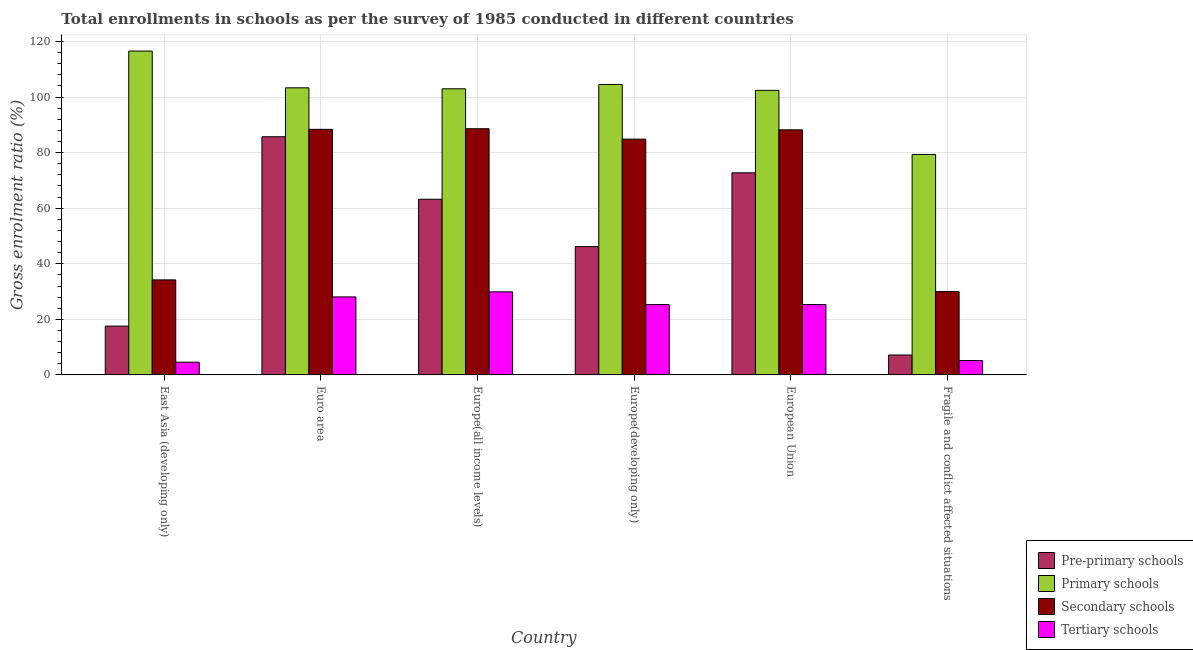How many groups of bars are there?
Keep it short and to the point. 6. How many bars are there on the 2nd tick from the left?
Give a very brief answer. 4. What is the gross enrolment ratio in pre-primary schools in Europe(developing only)?
Your response must be concise. 46.2. Across all countries, what is the maximum gross enrolment ratio in pre-primary schools?
Offer a very short reply. 85.72. Across all countries, what is the minimum gross enrolment ratio in secondary schools?
Give a very brief answer. 30.01. In which country was the gross enrolment ratio in primary schools maximum?
Provide a succinct answer. East Asia (developing only). In which country was the gross enrolment ratio in secondary schools minimum?
Your answer should be very brief. Fragile and conflict affected situations. What is the total gross enrolment ratio in tertiary schools in the graph?
Give a very brief answer. 118.38. What is the difference between the gross enrolment ratio in pre-primary schools in Euro area and that in Fragile and conflict affected situations?
Give a very brief answer. 78.56. What is the difference between the gross enrolment ratio in secondary schools in European Union and the gross enrolment ratio in tertiary schools in East Asia (developing only)?
Offer a very short reply. 83.63. What is the average gross enrolment ratio in secondary schools per country?
Ensure brevity in your answer.  69.05. What is the difference between the gross enrolment ratio in tertiary schools and gross enrolment ratio in pre-primary schools in Fragile and conflict affected situations?
Provide a succinct answer. -1.99. What is the ratio of the gross enrolment ratio in pre-primary schools in Europe(developing only) to that in Fragile and conflict affected situations?
Your response must be concise. 6.45. Is the gross enrolment ratio in secondary schools in Europe(all income levels) less than that in Europe(developing only)?
Your answer should be very brief. No. What is the difference between the highest and the second highest gross enrolment ratio in tertiary schools?
Offer a very short reply. 1.82. What is the difference between the highest and the lowest gross enrolment ratio in primary schools?
Your answer should be compact. 37.2. Is it the case that in every country, the sum of the gross enrolment ratio in tertiary schools and gross enrolment ratio in primary schools is greater than the sum of gross enrolment ratio in secondary schools and gross enrolment ratio in pre-primary schools?
Give a very brief answer. No. What does the 1st bar from the left in Europe(developing only) represents?
Your answer should be compact. Pre-primary schools. What does the 1st bar from the right in Europe(all income levels) represents?
Your answer should be compact. Tertiary schools. Are all the bars in the graph horizontal?
Keep it short and to the point. No. What is the difference between two consecutive major ticks on the Y-axis?
Offer a terse response. 20. How are the legend labels stacked?
Provide a succinct answer. Vertical. What is the title of the graph?
Provide a succinct answer. Total enrollments in schools as per the survey of 1985 conducted in different countries. What is the label or title of the X-axis?
Offer a terse response. Country. What is the Gross enrolment ratio (%) in Pre-primary schools in East Asia (developing only)?
Your answer should be compact. 17.57. What is the Gross enrolment ratio (%) of Primary schools in East Asia (developing only)?
Give a very brief answer. 116.56. What is the Gross enrolment ratio (%) of Secondary schools in East Asia (developing only)?
Provide a succinct answer. 34.21. What is the Gross enrolment ratio (%) of Tertiary schools in East Asia (developing only)?
Offer a terse response. 4.58. What is the Gross enrolment ratio (%) of Pre-primary schools in Euro area?
Make the answer very short. 85.72. What is the Gross enrolment ratio (%) of Primary schools in Euro area?
Provide a succinct answer. 103.33. What is the Gross enrolment ratio (%) in Secondary schools in Euro area?
Provide a succinct answer. 88.39. What is the Gross enrolment ratio (%) in Tertiary schools in Euro area?
Your answer should be very brief. 28.08. What is the Gross enrolment ratio (%) in Pre-primary schools in Europe(all income levels)?
Make the answer very short. 63.23. What is the Gross enrolment ratio (%) in Primary schools in Europe(all income levels)?
Provide a short and direct response. 102.99. What is the Gross enrolment ratio (%) in Secondary schools in Europe(all income levels)?
Offer a terse response. 88.61. What is the Gross enrolment ratio (%) in Tertiary schools in Europe(all income levels)?
Offer a very short reply. 29.9. What is the Gross enrolment ratio (%) in Pre-primary schools in Europe(developing only)?
Give a very brief answer. 46.2. What is the Gross enrolment ratio (%) of Primary schools in Europe(developing only)?
Provide a succinct answer. 104.55. What is the Gross enrolment ratio (%) of Secondary schools in Europe(developing only)?
Offer a very short reply. 84.86. What is the Gross enrolment ratio (%) of Tertiary schools in Europe(developing only)?
Offer a very short reply. 25.32. What is the Gross enrolment ratio (%) in Pre-primary schools in European Union?
Your answer should be compact. 72.74. What is the Gross enrolment ratio (%) of Primary schools in European Union?
Your answer should be compact. 102.42. What is the Gross enrolment ratio (%) of Secondary schools in European Union?
Give a very brief answer. 88.21. What is the Gross enrolment ratio (%) in Tertiary schools in European Union?
Provide a short and direct response. 25.33. What is the Gross enrolment ratio (%) of Pre-primary schools in Fragile and conflict affected situations?
Give a very brief answer. 7.16. What is the Gross enrolment ratio (%) of Primary schools in Fragile and conflict affected situations?
Make the answer very short. 79.36. What is the Gross enrolment ratio (%) in Secondary schools in Fragile and conflict affected situations?
Ensure brevity in your answer.  30.01. What is the Gross enrolment ratio (%) of Tertiary schools in Fragile and conflict affected situations?
Your answer should be compact. 5.17. Across all countries, what is the maximum Gross enrolment ratio (%) of Pre-primary schools?
Make the answer very short. 85.72. Across all countries, what is the maximum Gross enrolment ratio (%) of Primary schools?
Provide a short and direct response. 116.56. Across all countries, what is the maximum Gross enrolment ratio (%) of Secondary schools?
Your answer should be very brief. 88.61. Across all countries, what is the maximum Gross enrolment ratio (%) in Tertiary schools?
Provide a short and direct response. 29.9. Across all countries, what is the minimum Gross enrolment ratio (%) of Pre-primary schools?
Provide a succinct answer. 7.16. Across all countries, what is the minimum Gross enrolment ratio (%) of Primary schools?
Your answer should be compact. 79.36. Across all countries, what is the minimum Gross enrolment ratio (%) of Secondary schools?
Ensure brevity in your answer.  30.01. Across all countries, what is the minimum Gross enrolment ratio (%) in Tertiary schools?
Offer a terse response. 4.58. What is the total Gross enrolment ratio (%) of Pre-primary schools in the graph?
Offer a very short reply. 292.62. What is the total Gross enrolment ratio (%) in Primary schools in the graph?
Ensure brevity in your answer.  609.21. What is the total Gross enrolment ratio (%) of Secondary schools in the graph?
Provide a succinct answer. 414.27. What is the total Gross enrolment ratio (%) in Tertiary schools in the graph?
Provide a short and direct response. 118.38. What is the difference between the Gross enrolment ratio (%) in Pre-primary schools in East Asia (developing only) and that in Euro area?
Ensure brevity in your answer.  -68.16. What is the difference between the Gross enrolment ratio (%) in Primary schools in East Asia (developing only) and that in Euro area?
Provide a succinct answer. 13.23. What is the difference between the Gross enrolment ratio (%) of Secondary schools in East Asia (developing only) and that in Euro area?
Your answer should be compact. -54.18. What is the difference between the Gross enrolment ratio (%) of Tertiary schools in East Asia (developing only) and that in Euro area?
Make the answer very short. -23.5. What is the difference between the Gross enrolment ratio (%) in Pre-primary schools in East Asia (developing only) and that in Europe(all income levels)?
Provide a short and direct response. -45.66. What is the difference between the Gross enrolment ratio (%) in Primary schools in East Asia (developing only) and that in Europe(all income levels)?
Ensure brevity in your answer.  13.57. What is the difference between the Gross enrolment ratio (%) in Secondary schools in East Asia (developing only) and that in Europe(all income levels)?
Your answer should be compact. -54.4. What is the difference between the Gross enrolment ratio (%) in Tertiary schools in East Asia (developing only) and that in Europe(all income levels)?
Offer a terse response. -25.33. What is the difference between the Gross enrolment ratio (%) of Pre-primary schools in East Asia (developing only) and that in Europe(developing only)?
Offer a terse response. -28.63. What is the difference between the Gross enrolment ratio (%) of Primary schools in East Asia (developing only) and that in Europe(developing only)?
Keep it short and to the point. 12.01. What is the difference between the Gross enrolment ratio (%) in Secondary schools in East Asia (developing only) and that in Europe(developing only)?
Your response must be concise. -50.65. What is the difference between the Gross enrolment ratio (%) of Tertiary schools in East Asia (developing only) and that in Europe(developing only)?
Make the answer very short. -20.74. What is the difference between the Gross enrolment ratio (%) of Pre-primary schools in East Asia (developing only) and that in European Union?
Your answer should be very brief. -55.18. What is the difference between the Gross enrolment ratio (%) in Primary schools in East Asia (developing only) and that in European Union?
Your answer should be very brief. 14.14. What is the difference between the Gross enrolment ratio (%) of Secondary schools in East Asia (developing only) and that in European Union?
Keep it short and to the point. -54. What is the difference between the Gross enrolment ratio (%) in Tertiary schools in East Asia (developing only) and that in European Union?
Offer a very short reply. -20.75. What is the difference between the Gross enrolment ratio (%) in Pre-primary schools in East Asia (developing only) and that in Fragile and conflict affected situations?
Offer a terse response. 10.4. What is the difference between the Gross enrolment ratio (%) of Primary schools in East Asia (developing only) and that in Fragile and conflict affected situations?
Provide a succinct answer. 37.2. What is the difference between the Gross enrolment ratio (%) in Secondary schools in East Asia (developing only) and that in Fragile and conflict affected situations?
Offer a very short reply. 4.2. What is the difference between the Gross enrolment ratio (%) of Tertiary schools in East Asia (developing only) and that in Fragile and conflict affected situations?
Provide a succinct answer. -0.59. What is the difference between the Gross enrolment ratio (%) of Pre-primary schools in Euro area and that in Europe(all income levels)?
Offer a terse response. 22.49. What is the difference between the Gross enrolment ratio (%) of Primary schools in Euro area and that in Europe(all income levels)?
Provide a succinct answer. 0.34. What is the difference between the Gross enrolment ratio (%) in Secondary schools in Euro area and that in Europe(all income levels)?
Your answer should be very brief. -0.22. What is the difference between the Gross enrolment ratio (%) of Tertiary schools in Euro area and that in Europe(all income levels)?
Offer a very short reply. -1.82. What is the difference between the Gross enrolment ratio (%) in Pre-primary schools in Euro area and that in Europe(developing only)?
Ensure brevity in your answer.  39.52. What is the difference between the Gross enrolment ratio (%) in Primary schools in Euro area and that in Europe(developing only)?
Your answer should be very brief. -1.23. What is the difference between the Gross enrolment ratio (%) in Secondary schools in Euro area and that in Europe(developing only)?
Your answer should be very brief. 3.53. What is the difference between the Gross enrolment ratio (%) in Tertiary schools in Euro area and that in Europe(developing only)?
Your response must be concise. 2.76. What is the difference between the Gross enrolment ratio (%) in Pre-primary schools in Euro area and that in European Union?
Offer a terse response. 12.98. What is the difference between the Gross enrolment ratio (%) of Primary schools in Euro area and that in European Union?
Your response must be concise. 0.91. What is the difference between the Gross enrolment ratio (%) in Secondary schools in Euro area and that in European Union?
Ensure brevity in your answer.  0.18. What is the difference between the Gross enrolment ratio (%) of Tertiary schools in Euro area and that in European Union?
Ensure brevity in your answer.  2.75. What is the difference between the Gross enrolment ratio (%) of Pre-primary schools in Euro area and that in Fragile and conflict affected situations?
Your response must be concise. 78.56. What is the difference between the Gross enrolment ratio (%) in Primary schools in Euro area and that in Fragile and conflict affected situations?
Offer a terse response. 23.97. What is the difference between the Gross enrolment ratio (%) of Secondary schools in Euro area and that in Fragile and conflict affected situations?
Your answer should be very brief. 58.39. What is the difference between the Gross enrolment ratio (%) of Tertiary schools in Euro area and that in Fragile and conflict affected situations?
Your response must be concise. 22.91. What is the difference between the Gross enrolment ratio (%) of Pre-primary schools in Europe(all income levels) and that in Europe(developing only)?
Ensure brevity in your answer.  17.03. What is the difference between the Gross enrolment ratio (%) in Primary schools in Europe(all income levels) and that in Europe(developing only)?
Offer a terse response. -1.57. What is the difference between the Gross enrolment ratio (%) in Secondary schools in Europe(all income levels) and that in Europe(developing only)?
Ensure brevity in your answer.  3.75. What is the difference between the Gross enrolment ratio (%) in Tertiary schools in Europe(all income levels) and that in Europe(developing only)?
Your response must be concise. 4.59. What is the difference between the Gross enrolment ratio (%) of Pre-primary schools in Europe(all income levels) and that in European Union?
Give a very brief answer. -9.51. What is the difference between the Gross enrolment ratio (%) in Primary schools in Europe(all income levels) and that in European Union?
Keep it short and to the point. 0.57. What is the difference between the Gross enrolment ratio (%) in Secondary schools in Europe(all income levels) and that in European Union?
Keep it short and to the point. 0.4. What is the difference between the Gross enrolment ratio (%) of Tertiary schools in Europe(all income levels) and that in European Union?
Offer a very short reply. 4.57. What is the difference between the Gross enrolment ratio (%) of Pre-primary schools in Europe(all income levels) and that in Fragile and conflict affected situations?
Ensure brevity in your answer.  56.06. What is the difference between the Gross enrolment ratio (%) in Primary schools in Europe(all income levels) and that in Fragile and conflict affected situations?
Provide a short and direct response. 23.63. What is the difference between the Gross enrolment ratio (%) in Secondary schools in Europe(all income levels) and that in Fragile and conflict affected situations?
Make the answer very short. 58.6. What is the difference between the Gross enrolment ratio (%) of Tertiary schools in Europe(all income levels) and that in Fragile and conflict affected situations?
Ensure brevity in your answer.  24.73. What is the difference between the Gross enrolment ratio (%) in Pre-primary schools in Europe(developing only) and that in European Union?
Ensure brevity in your answer.  -26.54. What is the difference between the Gross enrolment ratio (%) of Primary schools in Europe(developing only) and that in European Union?
Your response must be concise. 2.13. What is the difference between the Gross enrolment ratio (%) in Secondary schools in Europe(developing only) and that in European Union?
Offer a terse response. -3.35. What is the difference between the Gross enrolment ratio (%) in Tertiary schools in Europe(developing only) and that in European Union?
Your answer should be very brief. -0.01. What is the difference between the Gross enrolment ratio (%) in Pre-primary schools in Europe(developing only) and that in Fragile and conflict affected situations?
Offer a terse response. 39.04. What is the difference between the Gross enrolment ratio (%) in Primary schools in Europe(developing only) and that in Fragile and conflict affected situations?
Make the answer very short. 25.2. What is the difference between the Gross enrolment ratio (%) of Secondary schools in Europe(developing only) and that in Fragile and conflict affected situations?
Keep it short and to the point. 54.85. What is the difference between the Gross enrolment ratio (%) of Tertiary schools in Europe(developing only) and that in Fragile and conflict affected situations?
Offer a very short reply. 20.15. What is the difference between the Gross enrolment ratio (%) of Pre-primary schools in European Union and that in Fragile and conflict affected situations?
Provide a short and direct response. 65.58. What is the difference between the Gross enrolment ratio (%) in Primary schools in European Union and that in Fragile and conflict affected situations?
Ensure brevity in your answer.  23.06. What is the difference between the Gross enrolment ratio (%) of Secondary schools in European Union and that in Fragile and conflict affected situations?
Provide a short and direct response. 58.2. What is the difference between the Gross enrolment ratio (%) in Tertiary schools in European Union and that in Fragile and conflict affected situations?
Your response must be concise. 20.16. What is the difference between the Gross enrolment ratio (%) of Pre-primary schools in East Asia (developing only) and the Gross enrolment ratio (%) of Primary schools in Euro area?
Ensure brevity in your answer.  -85.76. What is the difference between the Gross enrolment ratio (%) in Pre-primary schools in East Asia (developing only) and the Gross enrolment ratio (%) in Secondary schools in Euro area?
Offer a terse response. -70.83. What is the difference between the Gross enrolment ratio (%) in Pre-primary schools in East Asia (developing only) and the Gross enrolment ratio (%) in Tertiary schools in Euro area?
Your answer should be very brief. -10.51. What is the difference between the Gross enrolment ratio (%) of Primary schools in East Asia (developing only) and the Gross enrolment ratio (%) of Secondary schools in Euro area?
Provide a succinct answer. 28.17. What is the difference between the Gross enrolment ratio (%) in Primary schools in East Asia (developing only) and the Gross enrolment ratio (%) in Tertiary schools in Euro area?
Your answer should be compact. 88.48. What is the difference between the Gross enrolment ratio (%) in Secondary schools in East Asia (developing only) and the Gross enrolment ratio (%) in Tertiary schools in Euro area?
Your response must be concise. 6.13. What is the difference between the Gross enrolment ratio (%) in Pre-primary schools in East Asia (developing only) and the Gross enrolment ratio (%) in Primary schools in Europe(all income levels)?
Make the answer very short. -85.42. What is the difference between the Gross enrolment ratio (%) of Pre-primary schools in East Asia (developing only) and the Gross enrolment ratio (%) of Secondary schools in Europe(all income levels)?
Provide a short and direct response. -71.04. What is the difference between the Gross enrolment ratio (%) in Pre-primary schools in East Asia (developing only) and the Gross enrolment ratio (%) in Tertiary schools in Europe(all income levels)?
Provide a succinct answer. -12.34. What is the difference between the Gross enrolment ratio (%) in Primary schools in East Asia (developing only) and the Gross enrolment ratio (%) in Secondary schools in Europe(all income levels)?
Your response must be concise. 27.95. What is the difference between the Gross enrolment ratio (%) of Primary schools in East Asia (developing only) and the Gross enrolment ratio (%) of Tertiary schools in Europe(all income levels)?
Your answer should be very brief. 86.66. What is the difference between the Gross enrolment ratio (%) in Secondary schools in East Asia (developing only) and the Gross enrolment ratio (%) in Tertiary schools in Europe(all income levels)?
Provide a short and direct response. 4.3. What is the difference between the Gross enrolment ratio (%) of Pre-primary schools in East Asia (developing only) and the Gross enrolment ratio (%) of Primary schools in Europe(developing only)?
Your answer should be compact. -86.99. What is the difference between the Gross enrolment ratio (%) in Pre-primary schools in East Asia (developing only) and the Gross enrolment ratio (%) in Secondary schools in Europe(developing only)?
Provide a succinct answer. -67.29. What is the difference between the Gross enrolment ratio (%) of Pre-primary schools in East Asia (developing only) and the Gross enrolment ratio (%) of Tertiary schools in Europe(developing only)?
Your answer should be very brief. -7.75. What is the difference between the Gross enrolment ratio (%) in Primary schools in East Asia (developing only) and the Gross enrolment ratio (%) in Secondary schools in Europe(developing only)?
Your answer should be very brief. 31.7. What is the difference between the Gross enrolment ratio (%) of Primary schools in East Asia (developing only) and the Gross enrolment ratio (%) of Tertiary schools in Europe(developing only)?
Offer a very short reply. 91.24. What is the difference between the Gross enrolment ratio (%) in Secondary schools in East Asia (developing only) and the Gross enrolment ratio (%) in Tertiary schools in Europe(developing only)?
Make the answer very short. 8.89. What is the difference between the Gross enrolment ratio (%) in Pre-primary schools in East Asia (developing only) and the Gross enrolment ratio (%) in Primary schools in European Union?
Offer a very short reply. -84.85. What is the difference between the Gross enrolment ratio (%) in Pre-primary schools in East Asia (developing only) and the Gross enrolment ratio (%) in Secondary schools in European Union?
Your answer should be compact. -70.64. What is the difference between the Gross enrolment ratio (%) of Pre-primary schools in East Asia (developing only) and the Gross enrolment ratio (%) of Tertiary schools in European Union?
Make the answer very short. -7.77. What is the difference between the Gross enrolment ratio (%) in Primary schools in East Asia (developing only) and the Gross enrolment ratio (%) in Secondary schools in European Union?
Give a very brief answer. 28.35. What is the difference between the Gross enrolment ratio (%) of Primary schools in East Asia (developing only) and the Gross enrolment ratio (%) of Tertiary schools in European Union?
Your answer should be very brief. 91.23. What is the difference between the Gross enrolment ratio (%) in Secondary schools in East Asia (developing only) and the Gross enrolment ratio (%) in Tertiary schools in European Union?
Offer a very short reply. 8.88. What is the difference between the Gross enrolment ratio (%) of Pre-primary schools in East Asia (developing only) and the Gross enrolment ratio (%) of Primary schools in Fragile and conflict affected situations?
Offer a terse response. -61.79. What is the difference between the Gross enrolment ratio (%) of Pre-primary schools in East Asia (developing only) and the Gross enrolment ratio (%) of Secondary schools in Fragile and conflict affected situations?
Your response must be concise. -12.44. What is the difference between the Gross enrolment ratio (%) in Pre-primary schools in East Asia (developing only) and the Gross enrolment ratio (%) in Tertiary schools in Fragile and conflict affected situations?
Offer a very short reply. 12.39. What is the difference between the Gross enrolment ratio (%) of Primary schools in East Asia (developing only) and the Gross enrolment ratio (%) of Secondary schools in Fragile and conflict affected situations?
Ensure brevity in your answer.  86.56. What is the difference between the Gross enrolment ratio (%) in Primary schools in East Asia (developing only) and the Gross enrolment ratio (%) in Tertiary schools in Fragile and conflict affected situations?
Offer a very short reply. 111.39. What is the difference between the Gross enrolment ratio (%) of Secondary schools in East Asia (developing only) and the Gross enrolment ratio (%) of Tertiary schools in Fragile and conflict affected situations?
Provide a succinct answer. 29.04. What is the difference between the Gross enrolment ratio (%) of Pre-primary schools in Euro area and the Gross enrolment ratio (%) of Primary schools in Europe(all income levels)?
Keep it short and to the point. -17.26. What is the difference between the Gross enrolment ratio (%) in Pre-primary schools in Euro area and the Gross enrolment ratio (%) in Secondary schools in Europe(all income levels)?
Your answer should be very brief. -2.89. What is the difference between the Gross enrolment ratio (%) in Pre-primary schools in Euro area and the Gross enrolment ratio (%) in Tertiary schools in Europe(all income levels)?
Make the answer very short. 55.82. What is the difference between the Gross enrolment ratio (%) of Primary schools in Euro area and the Gross enrolment ratio (%) of Secondary schools in Europe(all income levels)?
Ensure brevity in your answer.  14.72. What is the difference between the Gross enrolment ratio (%) of Primary schools in Euro area and the Gross enrolment ratio (%) of Tertiary schools in Europe(all income levels)?
Offer a terse response. 73.43. What is the difference between the Gross enrolment ratio (%) in Secondary schools in Euro area and the Gross enrolment ratio (%) in Tertiary schools in Europe(all income levels)?
Provide a succinct answer. 58.49. What is the difference between the Gross enrolment ratio (%) in Pre-primary schools in Euro area and the Gross enrolment ratio (%) in Primary schools in Europe(developing only)?
Keep it short and to the point. -18.83. What is the difference between the Gross enrolment ratio (%) in Pre-primary schools in Euro area and the Gross enrolment ratio (%) in Secondary schools in Europe(developing only)?
Your answer should be very brief. 0.87. What is the difference between the Gross enrolment ratio (%) in Pre-primary schools in Euro area and the Gross enrolment ratio (%) in Tertiary schools in Europe(developing only)?
Offer a very short reply. 60.4. What is the difference between the Gross enrolment ratio (%) of Primary schools in Euro area and the Gross enrolment ratio (%) of Secondary schools in Europe(developing only)?
Make the answer very short. 18.47. What is the difference between the Gross enrolment ratio (%) of Primary schools in Euro area and the Gross enrolment ratio (%) of Tertiary schools in Europe(developing only)?
Ensure brevity in your answer.  78.01. What is the difference between the Gross enrolment ratio (%) in Secondary schools in Euro area and the Gross enrolment ratio (%) in Tertiary schools in Europe(developing only)?
Your response must be concise. 63.07. What is the difference between the Gross enrolment ratio (%) of Pre-primary schools in Euro area and the Gross enrolment ratio (%) of Primary schools in European Union?
Offer a very short reply. -16.7. What is the difference between the Gross enrolment ratio (%) in Pre-primary schools in Euro area and the Gross enrolment ratio (%) in Secondary schools in European Union?
Your response must be concise. -2.48. What is the difference between the Gross enrolment ratio (%) in Pre-primary schools in Euro area and the Gross enrolment ratio (%) in Tertiary schools in European Union?
Provide a succinct answer. 60.39. What is the difference between the Gross enrolment ratio (%) in Primary schools in Euro area and the Gross enrolment ratio (%) in Secondary schools in European Union?
Make the answer very short. 15.12. What is the difference between the Gross enrolment ratio (%) of Primary schools in Euro area and the Gross enrolment ratio (%) of Tertiary schools in European Union?
Give a very brief answer. 78. What is the difference between the Gross enrolment ratio (%) in Secondary schools in Euro area and the Gross enrolment ratio (%) in Tertiary schools in European Union?
Make the answer very short. 63.06. What is the difference between the Gross enrolment ratio (%) in Pre-primary schools in Euro area and the Gross enrolment ratio (%) in Primary schools in Fragile and conflict affected situations?
Offer a very short reply. 6.36. What is the difference between the Gross enrolment ratio (%) in Pre-primary schools in Euro area and the Gross enrolment ratio (%) in Secondary schools in Fragile and conflict affected situations?
Provide a short and direct response. 55.72. What is the difference between the Gross enrolment ratio (%) in Pre-primary schools in Euro area and the Gross enrolment ratio (%) in Tertiary schools in Fragile and conflict affected situations?
Your answer should be very brief. 80.55. What is the difference between the Gross enrolment ratio (%) of Primary schools in Euro area and the Gross enrolment ratio (%) of Secondary schools in Fragile and conflict affected situations?
Offer a very short reply. 73.32. What is the difference between the Gross enrolment ratio (%) of Primary schools in Euro area and the Gross enrolment ratio (%) of Tertiary schools in Fragile and conflict affected situations?
Provide a succinct answer. 98.16. What is the difference between the Gross enrolment ratio (%) of Secondary schools in Euro area and the Gross enrolment ratio (%) of Tertiary schools in Fragile and conflict affected situations?
Your answer should be very brief. 83.22. What is the difference between the Gross enrolment ratio (%) of Pre-primary schools in Europe(all income levels) and the Gross enrolment ratio (%) of Primary schools in Europe(developing only)?
Make the answer very short. -41.33. What is the difference between the Gross enrolment ratio (%) of Pre-primary schools in Europe(all income levels) and the Gross enrolment ratio (%) of Secondary schools in Europe(developing only)?
Your answer should be very brief. -21.63. What is the difference between the Gross enrolment ratio (%) in Pre-primary schools in Europe(all income levels) and the Gross enrolment ratio (%) in Tertiary schools in Europe(developing only)?
Your answer should be compact. 37.91. What is the difference between the Gross enrolment ratio (%) in Primary schools in Europe(all income levels) and the Gross enrolment ratio (%) in Secondary schools in Europe(developing only)?
Provide a succinct answer. 18.13. What is the difference between the Gross enrolment ratio (%) in Primary schools in Europe(all income levels) and the Gross enrolment ratio (%) in Tertiary schools in Europe(developing only)?
Offer a terse response. 77.67. What is the difference between the Gross enrolment ratio (%) in Secondary schools in Europe(all income levels) and the Gross enrolment ratio (%) in Tertiary schools in Europe(developing only)?
Provide a short and direct response. 63.29. What is the difference between the Gross enrolment ratio (%) of Pre-primary schools in Europe(all income levels) and the Gross enrolment ratio (%) of Primary schools in European Union?
Offer a very short reply. -39.19. What is the difference between the Gross enrolment ratio (%) in Pre-primary schools in Europe(all income levels) and the Gross enrolment ratio (%) in Secondary schools in European Union?
Make the answer very short. -24.98. What is the difference between the Gross enrolment ratio (%) of Pre-primary schools in Europe(all income levels) and the Gross enrolment ratio (%) of Tertiary schools in European Union?
Provide a succinct answer. 37.9. What is the difference between the Gross enrolment ratio (%) of Primary schools in Europe(all income levels) and the Gross enrolment ratio (%) of Secondary schools in European Union?
Offer a terse response. 14.78. What is the difference between the Gross enrolment ratio (%) in Primary schools in Europe(all income levels) and the Gross enrolment ratio (%) in Tertiary schools in European Union?
Provide a short and direct response. 77.66. What is the difference between the Gross enrolment ratio (%) of Secondary schools in Europe(all income levels) and the Gross enrolment ratio (%) of Tertiary schools in European Union?
Offer a very short reply. 63.28. What is the difference between the Gross enrolment ratio (%) in Pre-primary schools in Europe(all income levels) and the Gross enrolment ratio (%) in Primary schools in Fragile and conflict affected situations?
Provide a succinct answer. -16.13. What is the difference between the Gross enrolment ratio (%) in Pre-primary schools in Europe(all income levels) and the Gross enrolment ratio (%) in Secondary schools in Fragile and conflict affected situations?
Provide a short and direct response. 33.22. What is the difference between the Gross enrolment ratio (%) of Pre-primary schools in Europe(all income levels) and the Gross enrolment ratio (%) of Tertiary schools in Fragile and conflict affected situations?
Provide a short and direct response. 58.06. What is the difference between the Gross enrolment ratio (%) of Primary schools in Europe(all income levels) and the Gross enrolment ratio (%) of Secondary schools in Fragile and conflict affected situations?
Provide a succinct answer. 72.98. What is the difference between the Gross enrolment ratio (%) in Primary schools in Europe(all income levels) and the Gross enrolment ratio (%) in Tertiary schools in Fragile and conflict affected situations?
Provide a short and direct response. 97.82. What is the difference between the Gross enrolment ratio (%) of Secondary schools in Europe(all income levels) and the Gross enrolment ratio (%) of Tertiary schools in Fragile and conflict affected situations?
Keep it short and to the point. 83.44. What is the difference between the Gross enrolment ratio (%) in Pre-primary schools in Europe(developing only) and the Gross enrolment ratio (%) in Primary schools in European Union?
Your response must be concise. -56.22. What is the difference between the Gross enrolment ratio (%) in Pre-primary schools in Europe(developing only) and the Gross enrolment ratio (%) in Secondary schools in European Union?
Ensure brevity in your answer.  -42.01. What is the difference between the Gross enrolment ratio (%) in Pre-primary schools in Europe(developing only) and the Gross enrolment ratio (%) in Tertiary schools in European Union?
Provide a succinct answer. 20.87. What is the difference between the Gross enrolment ratio (%) of Primary schools in Europe(developing only) and the Gross enrolment ratio (%) of Secondary schools in European Union?
Your answer should be compact. 16.35. What is the difference between the Gross enrolment ratio (%) of Primary schools in Europe(developing only) and the Gross enrolment ratio (%) of Tertiary schools in European Union?
Make the answer very short. 79.22. What is the difference between the Gross enrolment ratio (%) in Secondary schools in Europe(developing only) and the Gross enrolment ratio (%) in Tertiary schools in European Union?
Make the answer very short. 59.53. What is the difference between the Gross enrolment ratio (%) of Pre-primary schools in Europe(developing only) and the Gross enrolment ratio (%) of Primary schools in Fragile and conflict affected situations?
Give a very brief answer. -33.16. What is the difference between the Gross enrolment ratio (%) in Pre-primary schools in Europe(developing only) and the Gross enrolment ratio (%) in Secondary schools in Fragile and conflict affected situations?
Keep it short and to the point. 16.2. What is the difference between the Gross enrolment ratio (%) of Pre-primary schools in Europe(developing only) and the Gross enrolment ratio (%) of Tertiary schools in Fragile and conflict affected situations?
Keep it short and to the point. 41.03. What is the difference between the Gross enrolment ratio (%) in Primary schools in Europe(developing only) and the Gross enrolment ratio (%) in Secondary schools in Fragile and conflict affected situations?
Your response must be concise. 74.55. What is the difference between the Gross enrolment ratio (%) in Primary schools in Europe(developing only) and the Gross enrolment ratio (%) in Tertiary schools in Fragile and conflict affected situations?
Keep it short and to the point. 99.38. What is the difference between the Gross enrolment ratio (%) in Secondary schools in Europe(developing only) and the Gross enrolment ratio (%) in Tertiary schools in Fragile and conflict affected situations?
Ensure brevity in your answer.  79.69. What is the difference between the Gross enrolment ratio (%) in Pre-primary schools in European Union and the Gross enrolment ratio (%) in Primary schools in Fragile and conflict affected situations?
Your answer should be compact. -6.62. What is the difference between the Gross enrolment ratio (%) in Pre-primary schools in European Union and the Gross enrolment ratio (%) in Secondary schools in Fragile and conflict affected situations?
Your response must be concise. 42.74. What is the difference between the Gross enrolment ratio (%) of Pre-primary schools in European Union and the Gross enrolment ratio (%) of Tertiary schools in Fragile and conflict affected situations?
Make the answer very short. 67.57. What is the difference between the Gross enrolment ratio (%) in Primary schools in European Union and the Gross enrolment ratio (%) in Secondary schools in Fragile and conflict affected situations?
Your answer should be very brief. 72.42. What is the difference between the Gross enrolment ratio (%) of Primary schools in European Union and the Gross enrolment ratio (%) of Tertiary schools in Fragile and conflict affected situations?
Provide a succinct answer. 97.25. What is the difference between the Gross enrolment ratio (%) of Secondary schools in European Union and the Gross enrolment ratio (%) of Tertiary schools in Fragile and conflict affected situations?
Your answer should be very brief. 83.04. What is the average Gross enrolment ratio (%) in Pre-primary schools per country?
Provide a short and direct response. 48.77. What is the average Gross enrolment ratio (%) in Primary schools per country?
Keep it short and to the point. 101.53. What is the average Gross enrolment ratio (%) in Secondary schools per country?
Provide a short and direct response. 69.05. What is the average Gross enrolment ratio (%) of Tertiary schools per country?
Give a very brief answer. 19.73. What is the difference between the Gross enrolment ratio (%) in Pre-primary schools and Gross enrolment ratio (%) in Primary schools in East Asia (developing only)?
Keep it short and to the point. -98.99. What is the difference between the Gross enrolment ratio (%) of Pre-primary schools and Gross enrolment ratio (%) of Secondary schools in East Asia (developing only)?
Make the answer very short. -16.64. What is the difference between the Gross enrolment ratio (%) of Pre-primary schools and Gross enrolment ratio (%) of Tertiary schools in East Asia (developing only)?
Provide a short and direct response. 12.99. What is the difference between the Gross enrolment ratio (%) in Primary schools and Gross enrolment ratio (%) in Secondary schools in East Asia (developing only)?
Offer a very short reply. 82.35. What is the difference between the Gross enrolment ratio (%) of Primary schools and Gross enrolment ratio (%) of Tertiary schools in East Asia (developing only)?
Keep it short and to the point. 111.98. What is the difference between the Gross enrolment ratio (%) in Secondary schools and Gross enrolment ratio (%) in Tertiary schools in East Asia (developing only)?
Make the answer very short. 29.63. What is the difference between the Gross enrolment ratio (%) of Pre-primary schools and Gross enrolment ratio (%) of Primary schools in Euro area?
Offer a terse response. -17.61. What is the difference between the Gross enrolment ratio (%) in Pre-primary schools and Gross enrolment ratio (%) in Secondary schools in Euro area?
Your response must be concise. -2.67. What is the difference between the Gross enrolment ratio (%) in Pre-primary schools and Gross enrolment ratio (%) in Tertiary schools in Euro area?
Keep it short and to the point. 57.64. What is the difference between the Gross enrolment ratio (%) of Primary schools and Gross enrolment ratio (%) of Secondary schools in Euro area?
Ensure brevity in your answer.  14.94. What is the difference between the Gross enrolment ratio (%) in Primary schools and Gross enrolment ratio (%) in Tertiary schools in Euro area?
Keep it short and to the point. 75.25. What is the difference between the Gross enrolment ratio (%) of Secondary schools and Gross enrolment ratio (%) of Tertiary schools in Euro area?
Keep it short and to the point. 60.31. What is the difference between the Gross enrolment ratio (%) in Pre-primary schools and Gross enrolment ratio (%) in Primary schools in Europe(all income levels)?
Give a very brief answer. -39.76. What is the difference between the Gross enrolment ratio (%) of Pre-primary schools and Gross enrolment ratio (%) of Secondary schools in Europe(all income levels)?
Ensure brevity in your answer.  -25.38. What is the difference between the Gross enrolment ratio (%) in Pre-primary schools and Gross enrolment ratio (%) in Tertiary schools in Europe(all income levels)?
Offer a terse response. 33.33. What is the difference between the Gross enrolment ratio (%) in Primary schools and Gross enrolment ratio (%) in Secondary schools in Europe(all income levels)?
Give a very brief answer. 14.38. What is the difference between the Gross enrolment ratio (%) of Primary schools and Gross enrolment ratio (%) of Tertiary schools in Europe(all income levels)?
Your answer should be compact. 73.08. What is the difference between the Gross enrolment ratio (%) in Secondary schools and Gross enrolment ratio (%) in Tertiary schools in Europe(all income levels)?
Keep it short and to the point. 58.7. What is the difference between the Gross enrolment ratio (%) in Pre-primary schools and Gross enrolment ratio (%) in Primary schools in Europe(developing only)?
Make the answer very short. -58.35. What is the difference between the Gross enrolment ratio (%) of Pre-primary schools and Gross enrolment ratio (%) of Secondary schools in Europe(developing only)?
Make the answer very short. -38.66. What is the difference between the Gross enrolment ratio (%) of Pre-primary schools and Gross enrolment ratio (%) of Tertiary schools in Europe(developing only)?
Offer a very short reply. 20.88. What is the difference between the Gross enrolment ratio (%) of Primary schools and Gross enrolment ratio (%) of Secondary schools in Europe(developing only)?
Provide a short and direct response. 19.7. What is the difference between the Gross enrolment ratio (%) of Primary schools and Gross enrolment ratio (%) of Tertiary schools in Europe(developing only)?
Give a very brief answer. 79.24. What is the difference between the Gross enrolment ratio (%) in Secondary schools and Gross enrolment ratio (%) in Tertiary schools in Europe(developing only)?
Your response must be concise. 59.54. What is the difference between the Gross enrolment ratio (%) in Pre-primary schools and Gross enrolment ratio (%) in Primary schools in European Union?
Make the answer very short. -29.68. What is the difference between the Gross enrolment ratio (%) in Pre-primary schools and Gross enrolment ratio (%) in Secondary schools in European Union?
Provide a short and direct response. -15.46. What is the difference between the Gross enrolment ratio (%) in Pre-primary schools and Gross enrolment ratio (%) in Tertiary schools in European Union?
Your answer should be very brief. 47.41. What is the difference between the Gross enrolment ratio (%) in Primary schools and Gross enrolment ratio (%) in Secondary schools in European Union?
Offer a very short reply. 14.21. What is the difference between the Gross enrolment ratio (%) of Primary schools and Gross enrolment ratio (%) of Tertiary schools in European Union?
Your answer should be very brief. 77.09. What is the difference between the Gross enrolment ratio (%) of Secondary schools and Gross enrolment ratio (%) of Tertiary schools in European Union?
Your answer should be compact. 62.88. What is the difference between the Gross enrolment ratio (%) of Pre-primary schools and Gross enrolment ratio (%) of Primary schools in Fragile and conflict affected situations?
Make the answer very short. -72.19. What is the difference between the Gross enrolment ratio (%) of Pre-primary schools and Gross enrolment ratio (%) of Secondary schools in Fragile and conflict affected situations?
Your answer should be very brief. -22.84. What is the difference between the Gross enrolment ratio (%) of Pre-primary schools and Gross enrolment ratio (%) of Tertiary schools in Fragile and conflict affected situations?
Provide a succinct answer. 1.99. What is the difference between the Gross enrolment ratio (%) of Primary schools and Gross enrolment ratio (%) of Secondary schools in Fragile and conflict affected situations?
Give a very brief answer. 49.35. What is the difference between the Gross enrolment ratio (%) in Primary schools and Gross enrolment ratio (%) in Tertiary schools in Fragile and conflict affected situations?
Your answer should be very brief. 74.19. What is the difference between the Gross enrolment ratio (%) in Secondary schools and Gross enrolment ratio (%) in Tertiary schools in Fragile and conflict affected situations?
Your response must be concise. 24.83. What is the ratio of the Gross enrolment ratio (%) in Pre-primary schools in East Asia (developing only) to that in Euro area?
Give a very brief answer. 0.2. What is the ratio of the Gross enrolment ratio (%) of Primary schools in East Asia (developing only) to that in Euro area?
Your answer should be very brief. 1.13. What is the ratio of the Gross enrolment ratio (%) of Secondary schools in East Asia (developing only) to that in Euro area?
Provide a short and direct response. 0.39. What is the ratio of the Gross enrolment ratio (%) in Tertiary schools in East Asia (developing only) to that in Euro area?
Ensure brevity in your answer.  0.16. What is the ratio of the Gross enrolment ratio (%) of Pre-primary schools in East Asia (developing only) to that in Europe(all income levels)?
Your answer should be compact. 0.28. What is the ratio of the Gross enrolment ratio (%) in Primary schools in East Asia (developing only) to that in Europe(all income levels)?
Make the answer very short. 1.13. What is the ratio of the Gross enrolment ratio (%) of Secondary schools in East Asia (developing only) to that in Europe(all income levels)?
Your answer should be compact. 0.39. What is the ratio of the Gross enrolment ratio (%) in Tertiary schools in East Asia (developing only) to that in Europe(all income levels)?
Offer a terse response. 0.15. What is the ratio of the Gross enrolment ratio (%) in Pre-primary schools in East Asia (developing only) to that in Europe(developing only)?
Your response must be concise. 0.38. What is the ratio of the Gross enrolment ratio (%) of Primary schools in East Asia (developing only) to that in Europe(developing only)?
Offer a very short reply. 1.11. What is the ratio of the Gross enrolment ratio (%) in Secondary schools in East Asia (developing only) to that in Europe(developing only)?
Provide a succinct answer. 0.4. What is the ratio of the Gross enrolment ratio (%) in Tertiary schools in East Asia (developing only) to that in Europe(developing only)?
Give a very brief answer. 0.18. What is the ratio of the Gross enrolment ratio (%) of Pre-primary schools in East Asia (developing only) to that in European Union?
Give a very brief answer. 0.24. What is the ratio of the Gross enrolment ratio (%) of Primary schools in East Asia (developing only) to that in European Union?
Provide a succinct answer. 1.14. What is the ratio of the Gross enrolment ratio (%) of Secondary schools in East Asia (developing only) to that in European Union?
Make the answer very short. 0.39. What is the ratio of the Gross enrolment ratio (%) in Tertiary schools in East Asia (developing only) to that in European Union?
Give a very brief answer. 0.18. What is the ratio of the Gross enrolment ratio (%) in Pre-primary schools in East Asia (developing only) to that in Fragile and conflict affected situations?
Keep it short and to the point. 2.45. What is the ratio of the Gross enrolment ratio (%) of Primary schools in East Asia (developing only) to that in Fragile and conflict affected situations?
Offer a terse response. 1.47. What is the ratio of the Gross enrolment ratio (%) of Secondary schools in East Asia (developing only) to that in Fragile and conflict affected situations?
Your response must be concise. 1.14. What is the ratio of the Gross enrolment ratio (%) of Tertiary schools in East Asia (developing only) to that in Fragile and conflict affected situations?
Ensure brevity in your answer.  0.89. What is the ratio of the Gross enrolment ratio (%) of Pre-primary schools in Euro area to that in Europe(all income levels)?
Provide a succinct answer. 1.36. What is the ratio of the Gross enrolment ratio (%) in Tertiary schools in Euro area to that in Europe(all income levels)?
Keep it short and to the point. 0.94. What is the ratio of the Gross enrolment ratio (%) of Pre-primary schools in Euro area to that in Europe(developing only)?
Ensure brevity in your answer.  1.86. What is the ratio of the Gross enrolment ratio (%) in Primary schools in Euro area to that in Europe(developing only)?
Keep it short and to the point. 0.99. What is the ratio of the Gross enrolment ratio (%) of Secondary schools in Euro area to that in Europe(developing only)?
Keep it short and to the point. 1.04. What is the ratio of the Gross enrolment ratio (%) in Tertiary schools in Euro area to that in Europe(developing only)?
Provide a succinct answer. 1.11. What is the ratio of the Gross enrolment ratio (%) in Pre-primary schools in Euro area to that in European Union?
Give a very brief answer. 1.18. What is the ratio of the Gross enrolment ratio (%) of Primary schools in Euro area to that in European Union?
Offer a terse response. 1.01. What is the ratio of the Gross enrolment ratio (%) in Secondary schools in Euro area to that in European Union?
Your response must be concise. 1. What is the ratio of the Gross enrolment ratio (%) in Tertiary schools in Euro area to that in European Union?
Offer a very short reply. 1.11. What is the ratio of the Gross enrolment ratio (%) of Pre-primary schools in Euro area to that in Fragile and conflict affected situations?
Make the answer very short. 11.96. What is the ratio of the Gross enrolment ratio (%) of Primary schools in Euro area to that in Fragile and conflict affected situations?
Give a very brief answer. 1.3. What is the ratio of the Gross enrolment ratio (%) of Secondary schools in Euro area to that in Fragile and conflict affected situations?
Ensure brevity in your answer.  2.95. What is the ratio of the Gross enrolment ratio (%) in Tertiary schools in Euro area to that in Fragile and conflict affected situations?
Give a very brief answer. 5.43. What is the ratio of the Gross enrolment ratio (%) of Pre-primary schools in Europe(all income levels) to that in Europe(developing only)?
Provide a succinct answer. 1.37. What is the ratio of the Gross enrolment ratio (%) of Secondary schools in Europe(all income levels) to that in Europe(developing only)?
Offer a terse response. 1.04. What is the ratio of the Gross enrolment ratio (%) of Tertiary schools in Europe(all income levels) to that in Europe(developing only)?
Offer a terse response. 1.18. What is the ratio of the Gross enrolment ratio (%) in Pre-primary schools in Europe(all income levels) to that in European Union?
Provide a short and direct response. 0.87. What is the ratio of the Gross enrolment ratio (%) in Tertiary schools in Europe(all income levels) to that in European Union?
Keep it short and to the point. 1.18. What is the ratio of the Gross enrolment ratio (%) in Pre-primary schools in Europe(all income levels) to that in Fragile and conflict affected situations?
Ensure brevity in your answer.  8.82. What is the ratio of the Gross enrolment ratio (%) in Primary schools in Europe(all income levels) to that in Fragile and conflict affected situations?
Your answer should be compact. 1.3. What is the ratio of the Gross enrolment ratio (%) in Secondary schools in Europe(all income levels) to that in Fragile and conflict affected situations?
Make the answer very short. 2.95. What is the ratio of the Gross enrolment ratio (%) of Tertiary schools in Europe(all income levels) to that in Fragile and conflict affected situations?
Give a very brief answer. 5.78. What is the ratio of the Gross enrolment ratio (%) of Pre-primary schools in Europe(developing only) to that in European Union?
Ensure brevity in your answer.  0.64. What is the ratio of the Gross enrolment ratio (%) of Primary schools in Europe(developing only) to that in European Union?
Offer a very short reply. 1.02. What is the ratio of the Gross enrolment ratio (%) of Pre-primary schools in Europe(developing only) to that in Fragile and conflict affected situations?
Your answer should be very brief. 6.45. What is the ratio of the Gross enrolment ratio (%) of Primary schools in Europe(developing only) to that in Fragile and conflict affected situations?
Your answer should be compact. 1.32. What is the ratio of the Gross enrolment ratio (%) in Secondary schools in Europe(developing only) to that in Fragile and conflict affected situations?
Give a very brief answer. 2.83. What is the ratio of the Gross enrolment ratio (%) of Tertiary schools in Europe(developing only) to that in Fragile and conflict affected situations?
Your response must be concise. 4.9. What is the ratio of the Gross enrolment ratio (%) in Pre-primary schools in European Union to that in Fragile and conflict affected situations?
Give a very brief answer. 10.15. What is the ratio of the Gross enrolment ratio (%) in Primary schools in European Union to that in Fragile and conflict affected situations?
Ensure brevity in your answer.  1.29. What is the ratio of the Gross enrolment ratio (%) of Secondary schools in European Union to that in Fragile and conflict affected situations?
Your response must be concise. 2.94. What is the ratio of the Gross enrolment ratio (%) of Tertiary schools in European Union to that in Fragile and conflict affected situations?
Your answer should be compact. 4.9. What is the difference between the highest and the second highest Gross enrolment ratio (%) of Pre-primary schools?
Provide a succinct answer. 12.98. What is the difference between the highest and the second highest Gross enrolment ratio (%) of Primary schools?
Provide a short and direct response. 12.01. What is the difference between the highest and the second highest Gross enrolment ratio (%) in Secondary schools?
Give a very brief answer. 0.22. What is the difference between the highest and the second highest Gross enrolment ratio (%) in Tertiary schools?
Offer a very short reply. 1.82. What is the difference between the highest and the lowest Gross enrolment ratio (%) of Pre-primary schools?
Offer a terse response. 78.56. What is the difference between the highest and the lowest Gross enrolment ratio (%) of Primary schools?
Offer a very short reply. 37.2. What is the difference between the highest and the lowest Gross enrolment ratio (%) in Secondary schools?
Offer a very short reply. 58.6. What is the difference between the highest and the lowest Gross enrolment ratio (%) of Tertiary schools?
Offer a very short reply. 25.33. 